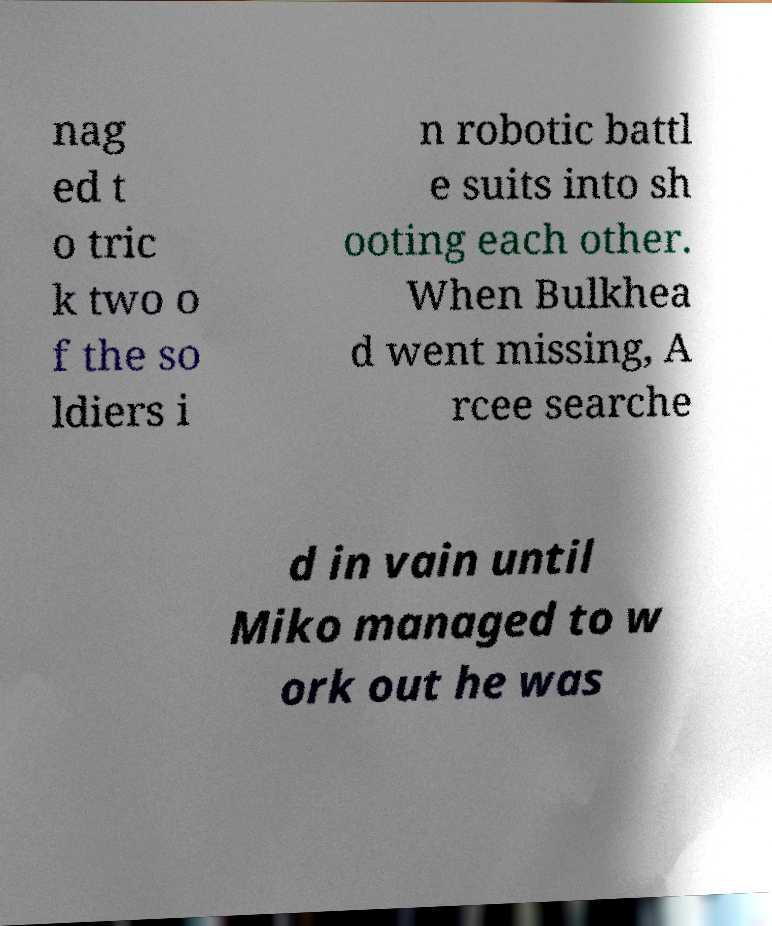Could you extract and type out the text from this image? nag ed t o tric k two o f the so ldiers i n robotic battl e suits into sh ooting each other. When Bulkhea d went missing, A rcee searche d in vain until Miko managed to w ork out he was 